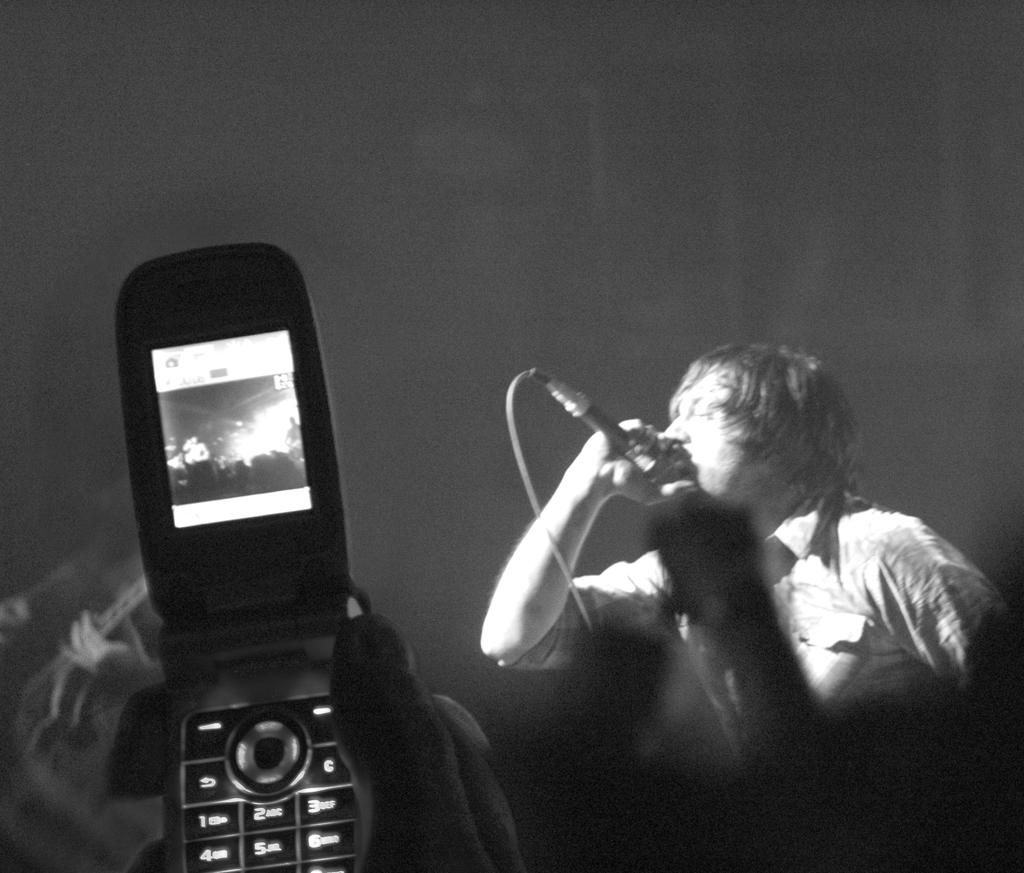What object can be seen in the image that is commonly used for communication? There is a phone in the image. What activity is the person in the image engaged in? The person is singing in the image. What tool is the person using to amplify their voice while singing? The person is holding a microphone in their hand. How many clovers are visible in the image? There are no clovers present in the image. What type of pets can be seen accompanying the person while they sing? There are no pets visible in the image. 